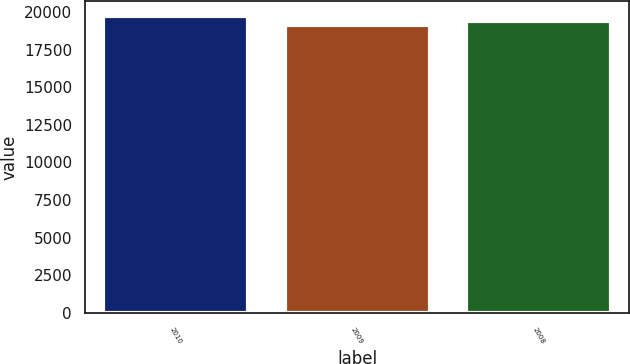Convert chart to OTSL. <chart><loc_0><loc_0><loc_500><loc_500><bar_chart><fcel>2010<fcel>2009<fcel>2008<nl><fcel>19746<fcel>19115<fcel>19415<nl></chart> 